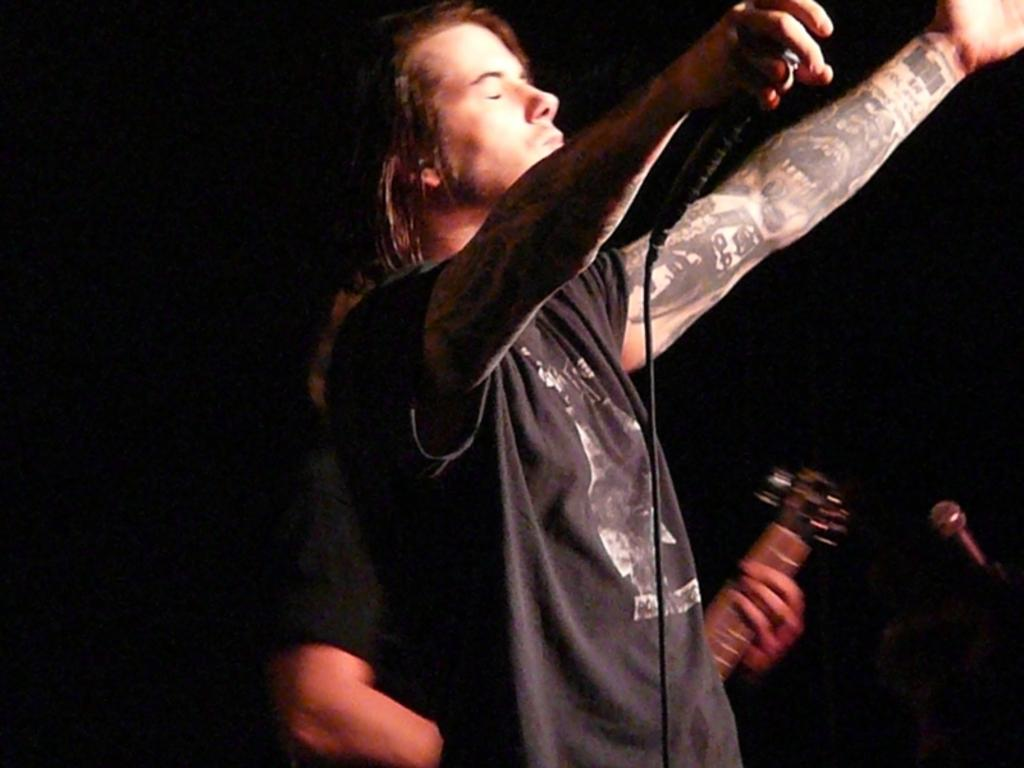What is the main subject of the image? There is a person standing in the image. What type of rifle is the person holding in the image? There is no rifle present in the image; it only shows a person standing. What kind of lumber is visible in the image? There is no lumber present in the image; it only shows a person standing. 